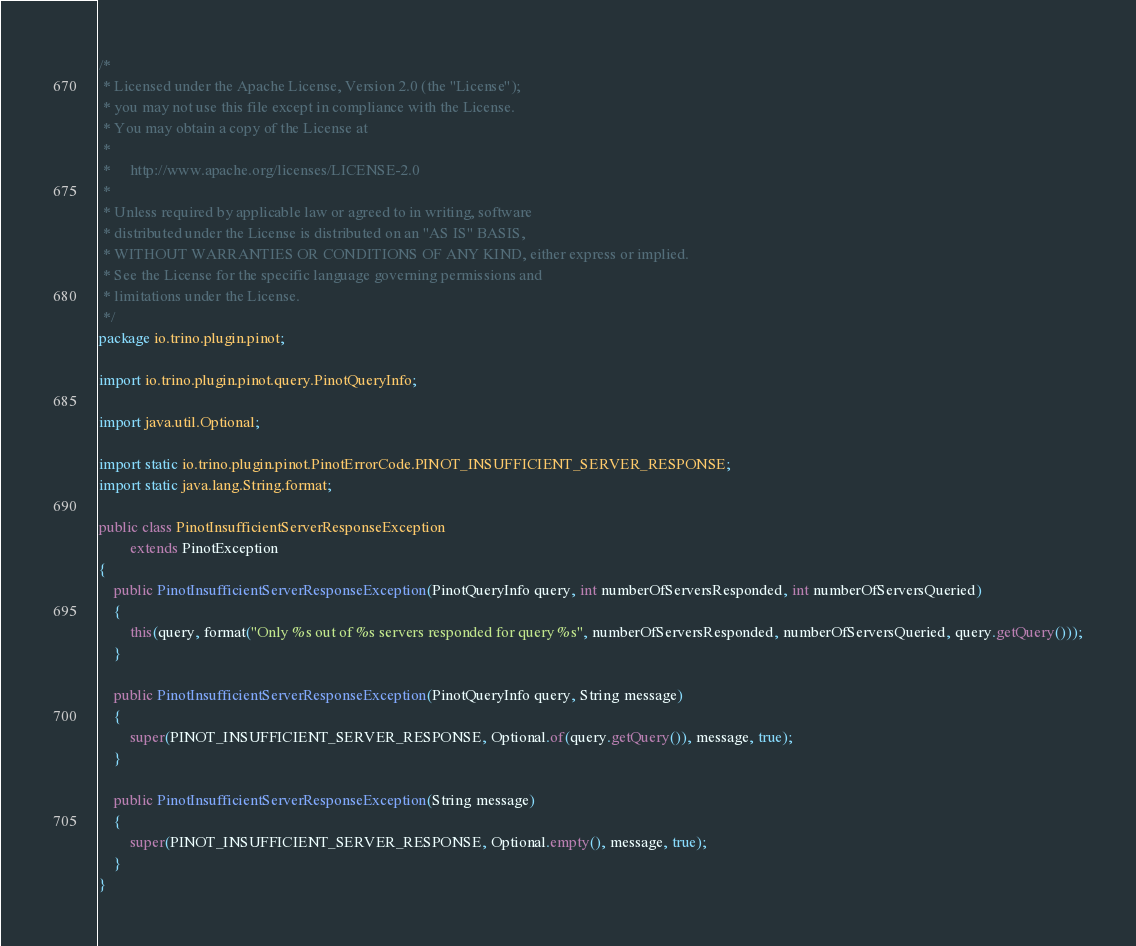<code> <loc_0><loc_0><loc_500><loc_500><_Java_>/*
 * Licensed under the Apache License, Version 2.0 (the "License");
 * you may not use this file except in compliance with the License.
 * You may obtain a copy of the License at
 *
 *     http://www.apache.org/licenses/LICENSE-2.0
 *
 * Unless required by applicable law or agreed to in writing, software
 * distributed under the License is distributed on an "AS IS" BASIS,
 * WITHOUT WARRANTIES OR CONDITIONS OF ANY KIND, either express or implied.
 * See the License for the specific language governing permissions and
 * limitations under the License.
 */
package io.trino.plugin.pinot;

import io.trino.plugin.pinot.query.PinotQueryInfo;

import java.util.Optional;

import static io.trino.plugin.pinot.PinotErrorCode.PINOT_INSUFFICIENT_SERVER_RESPONSE;
import static java.lang.String.format;

public class PinotInsufficientServerResponseException
        extends PinotException
{
    public PinotInsufficientServerResponseException(PinotQueryInfo query, int numberOfServersResponded, int numberOfServersQueried)
    {
        this(query, format("Only %s out of %s servers responded for query %s", numberOfServersResponded, numberOfServersQueried, query.getQuery()));
    }

    public PinotInsufficientServerResponseException(PinotQueryInfo query, String message)
    {
        super(PINOT_INSUFFICIENT_SERVER_RESPONSE, Optional.of(query.getQuery()), message, true);
    }

    public PinotInsufficientServerResponseException(String message)
    {
        super(PINOT_INSUFFICIENT_SERVER_RESPONSE, Optional.empty(), message, true);
    }
}
</code> 